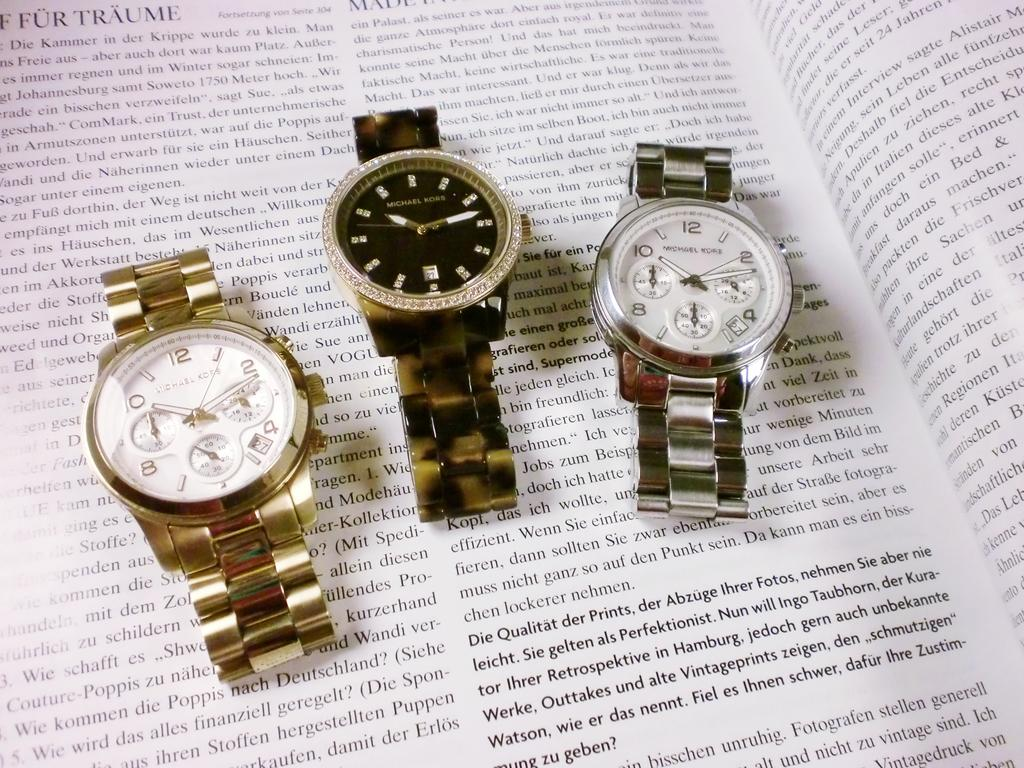<image>
Offer a succinct explanation of the picture presented. Three Michael Kors watches placed on top of a book. 